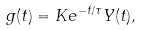<formula> <loc_0><loc_0><loc_500><loc_500>g ( t ) = K e ^ { - t / \tau } Y ( t ) ,</formula> 